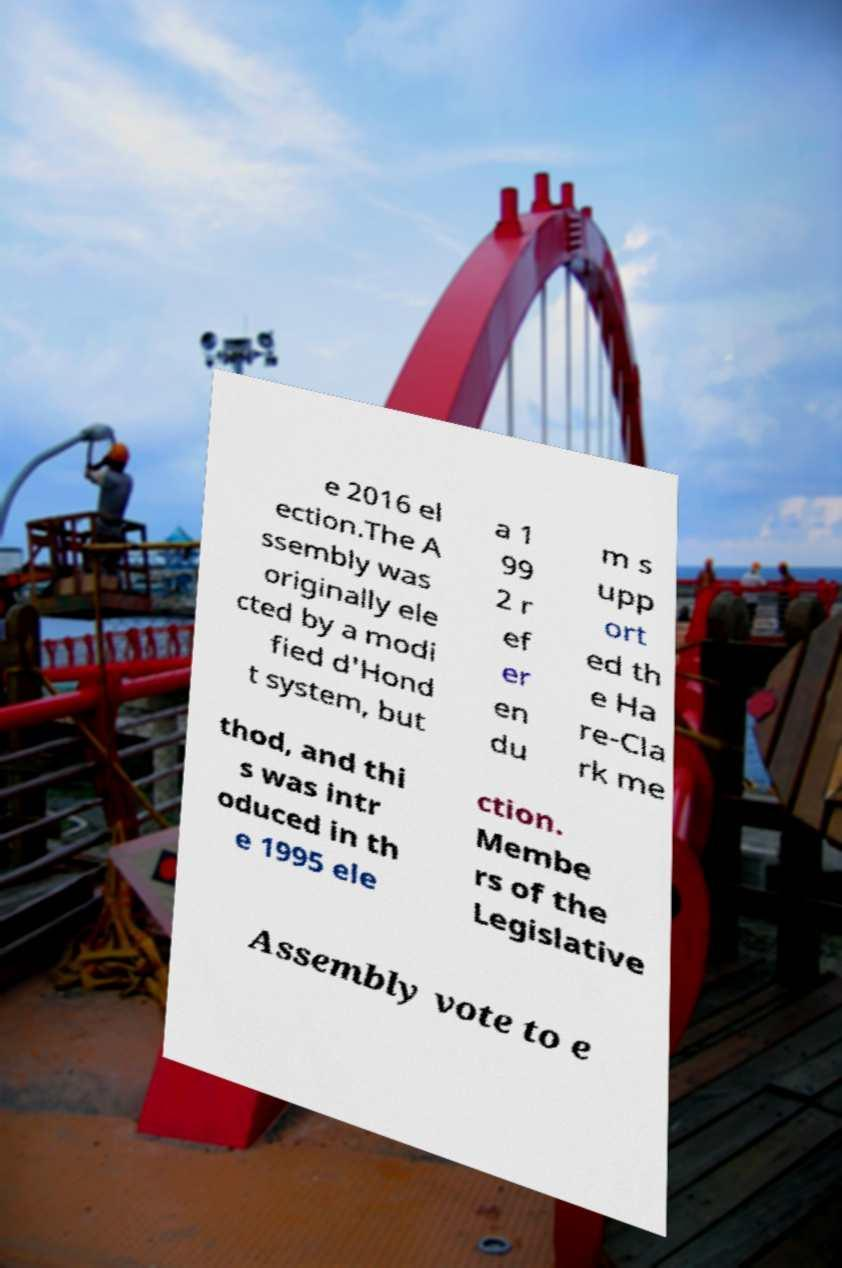Can you accurately transcribe the text from the provided image for me? e 2016 el ection.The A ssembly was originally ele cted by a modi fied d'Hond t system, but a 1 99 2 r ef er en du m s upp ort ed th e Ha re-Cla rk me thod, and thi s was intr oduced in th e 1995 ele ction. Membe rs of the Legislative Assembly vote to e 